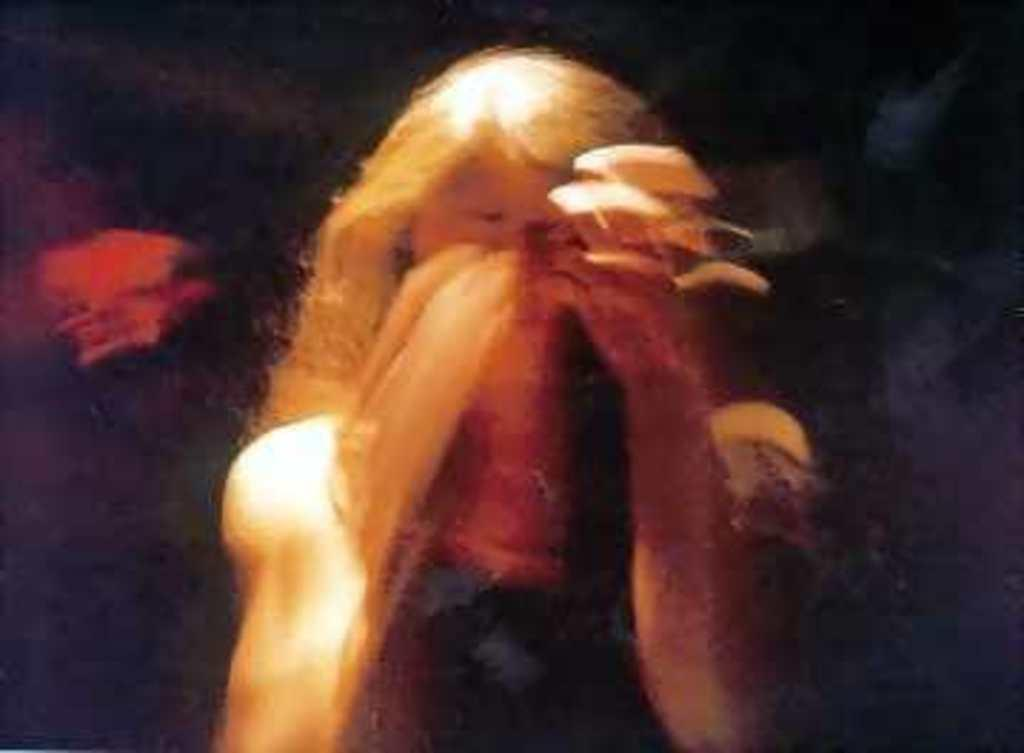What is the main subject in the foreground of the image? There is a person in the foreground of the image. How would you describe the background of the image? The background of the image appears blurred. What type of loaf is being offered by the person in the image? There is no loaf present in the image, and the person is not offering anything. 